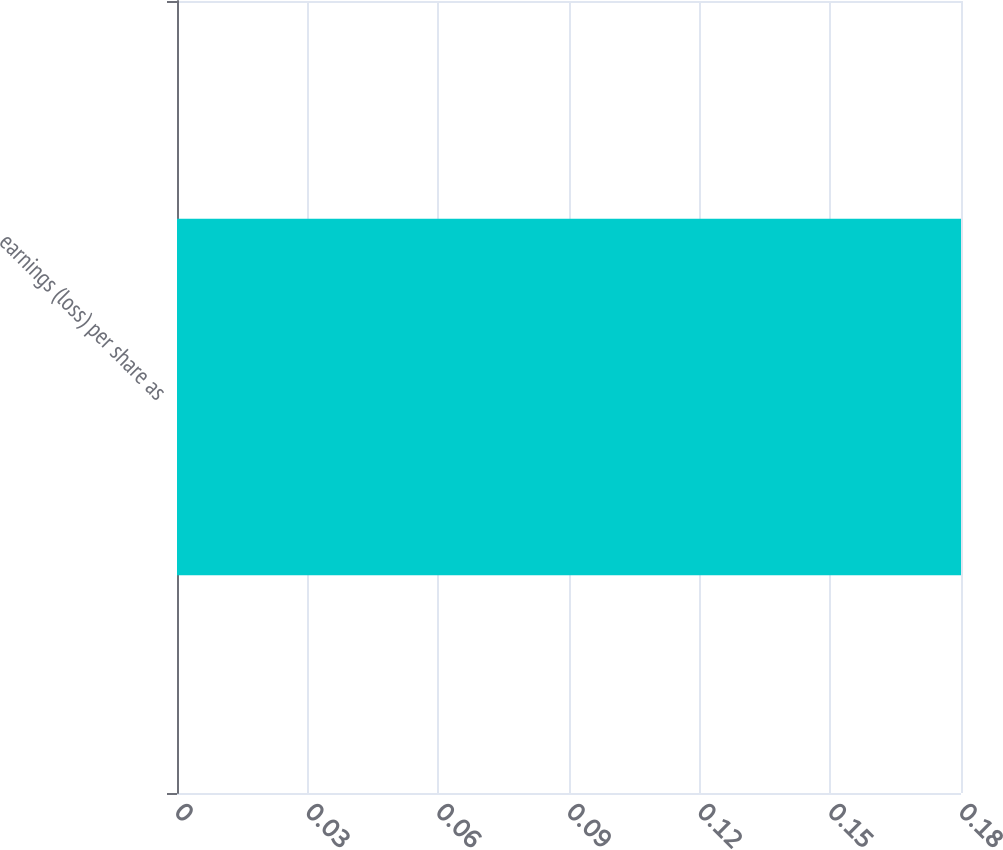<chart> <loc_0><loc_0><loc_500><loc_500><bar_chart><fcel>earnings (loss) per share as<nl><fcel>0.18<nl></chart> 